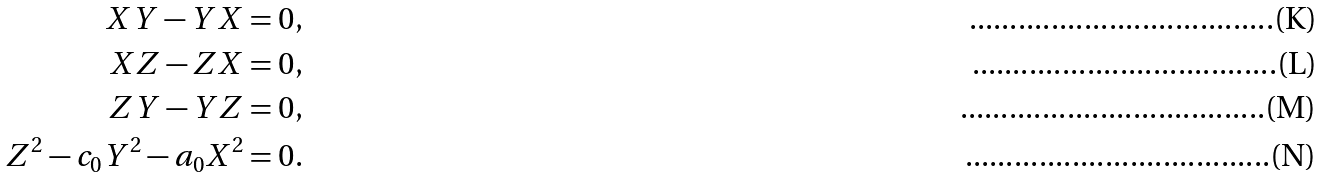Convert formula to latex. <formula><loc_0><loc_0><loc_500><loc_500>X Y - Y X = 0 , \\ X Z - Z X = 0 , \\ Z Y - Y Z = 0 , \\ Z ^ { 2 } - c _ { 0 } Y ^ { 2 } - a _ { 0 } X ^ { 2 } = 0 .</formula> 